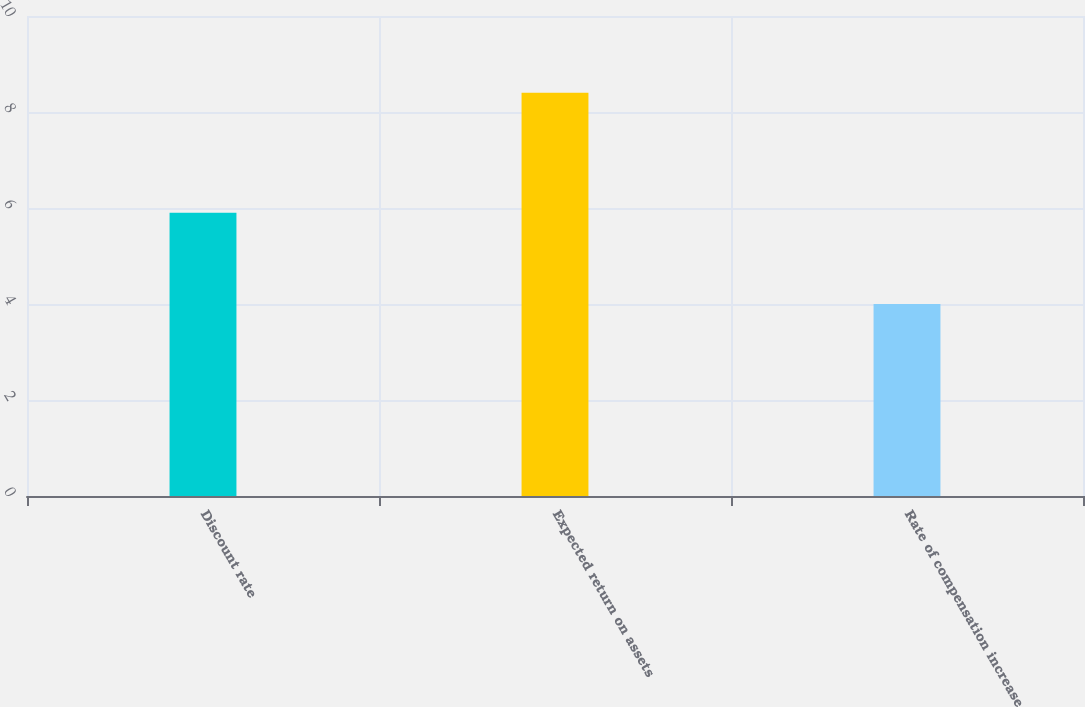Convert chart. <chart><loc_0><loc_0><loc_500><loc_500><bar_chart><fcel>Discount rate<fcel>Expected return on assets<fcel>Rate of compensation increase<nl><fcel>5.9<fcel>8.4<fcel>4<nl></chart> 